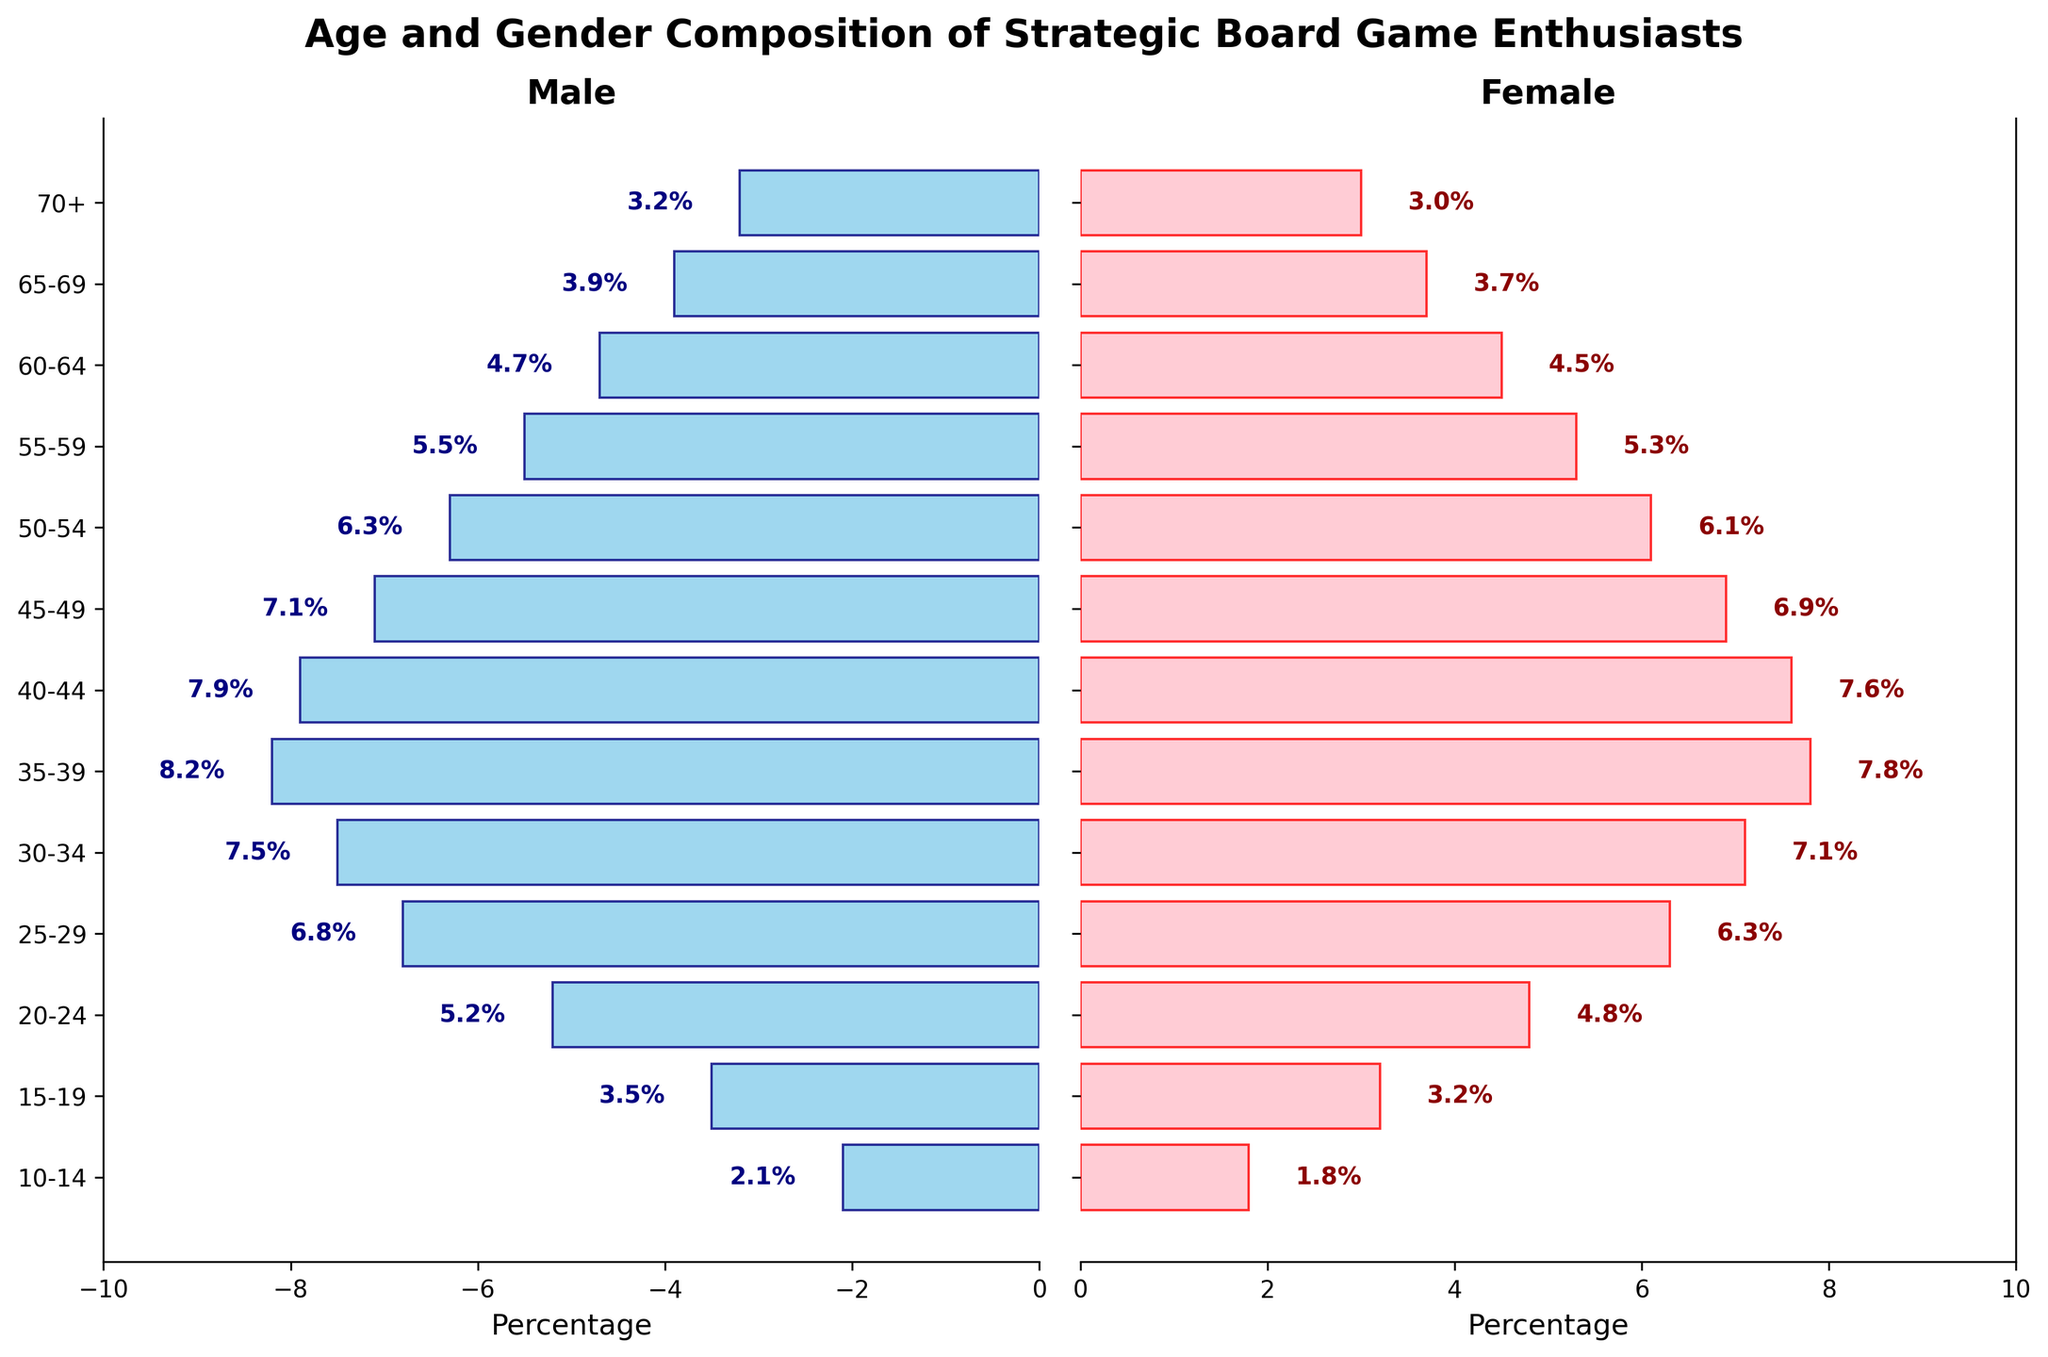What is the title of the figure? The title is written at the top of the figure in bold font, encapsulating the main subject of the visualization.
Answer: Age and Gender Composition of Strategic Board Game Enthusiasts How many age groups are represented in the figure? The figure shows horizontal bars for different age groups along the y-axis, each representing a distinct category. By counting these bars, we find that there are 13 age groups depicted.
Answer: 13 Which age group has the highest percentage of female enthusiasts? By examining the length of the female bars (pink, on the right side of the plot), we determine that the age group with the longest bar indicates the highest percentage. The age group 35-39 has the highest percentage of female enthusiasts at 7.8%.
Answer: 35-39 What's the sum of the percentages for male enthusiasts aged 20-24 and 25-29? We look at the lengths of the blue bars for the age groups 20-24 and 25-29 and then sum their percentages. For age 20-24 the value is 5.2, and for age 25-29 it is 6.8. Summing these gives us 5.2 + 6.8 = 12.
Answer: 12 Are there more male or female enthusiasts aged 30-34? Compare the lengths of the blue bar (male) and the pink bar (female) for the age group 30-34. The male percentage is 7.5%, whereas the female percentage is 7.1%. Therefore, there are more male enthusiasts in this age group.
Answer: Male What's the average percentage of male enthusiasts for the age groups between 50 and 59? Calculate the average for the given age groups by summing their percentages and then dividing by the number of groups. For ages 50-54 and 55-59, the values are 6.3 and 5.5. The sum is 6.3 + 5.5 = 11.8. Dividing by 2, the average is 11.8 / 2 = 5.9.
Answer: 5.9 In which age group do males and females have the closest percentages? Look for bars that are almost equal in length for both genders. The age group 45-49 has the male percentage at 7.1% and the female percentage at 6.9%, showing the smallest difference of 0.2%.
Answer: 45-49 Which gender has more enthusiasts in the age group 10-14? Compare the lengths of the blue and pink bars for age group 10-14. The male percentage is 2.1% and the female percentage is 1.8%, indicating more male enthusiasts.
Answer: Male What is the combined percentage of enthusiasts aged 70+? To find the total percentage of enthusiasts aged 70 and older, sum the percentages of both males (3.2) and females (3.0). So, 3.2 + 3.0 = 6.2.
Answer: 6.2 